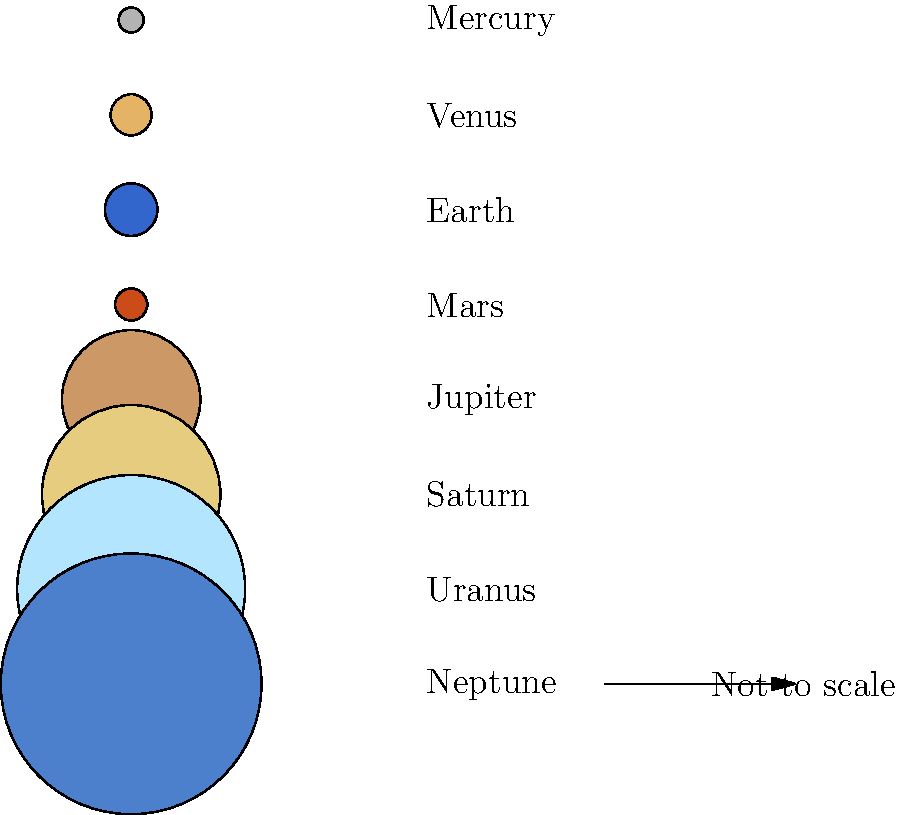In the context of healthcare policy analysis, understanding scale and proportion is crucial. If we apply this concept to our solar system, which planet's size is most disproportionately represented in this diagram compared to its actual size relative to Earth? To answer this question, we need to compare the relative sizes shown in the diagram with the actual relative sizes of the planets:

1. In the diagram, the sizes are based on the logarithm of the planet's radius plus 1, which compresses the scale.

2. Actual relative sizes (Earth = 1):
   Mercury: 0.38
   Venus: 0.95
   Earth: 1.00
   Mars: 0.53
   Jupiter: 11.21
   Saturn: 9.45
   Uranus: 4.01
   Neptune: 3.88

3. In the diagram, Jupiter appears only slightly larger than Earth, while Saturn looks similar in size to Jupiter.

4. In reality, Jupiter is about 11 times larger than Earth in radius, while Saturn is about 9.5 times larger.

5. The most significant discrepancy is with Jupiter, as its actual size is vastly larger than Earth, but this difference is not well-represented in the logarithmic scale used in the diagram.

This question highlights the importance of understanding how data representation can affect perception, which is crucial in healthcare policy analysis when dealing with statistics and visual representations of health disparities.
Answer: Jupiter 